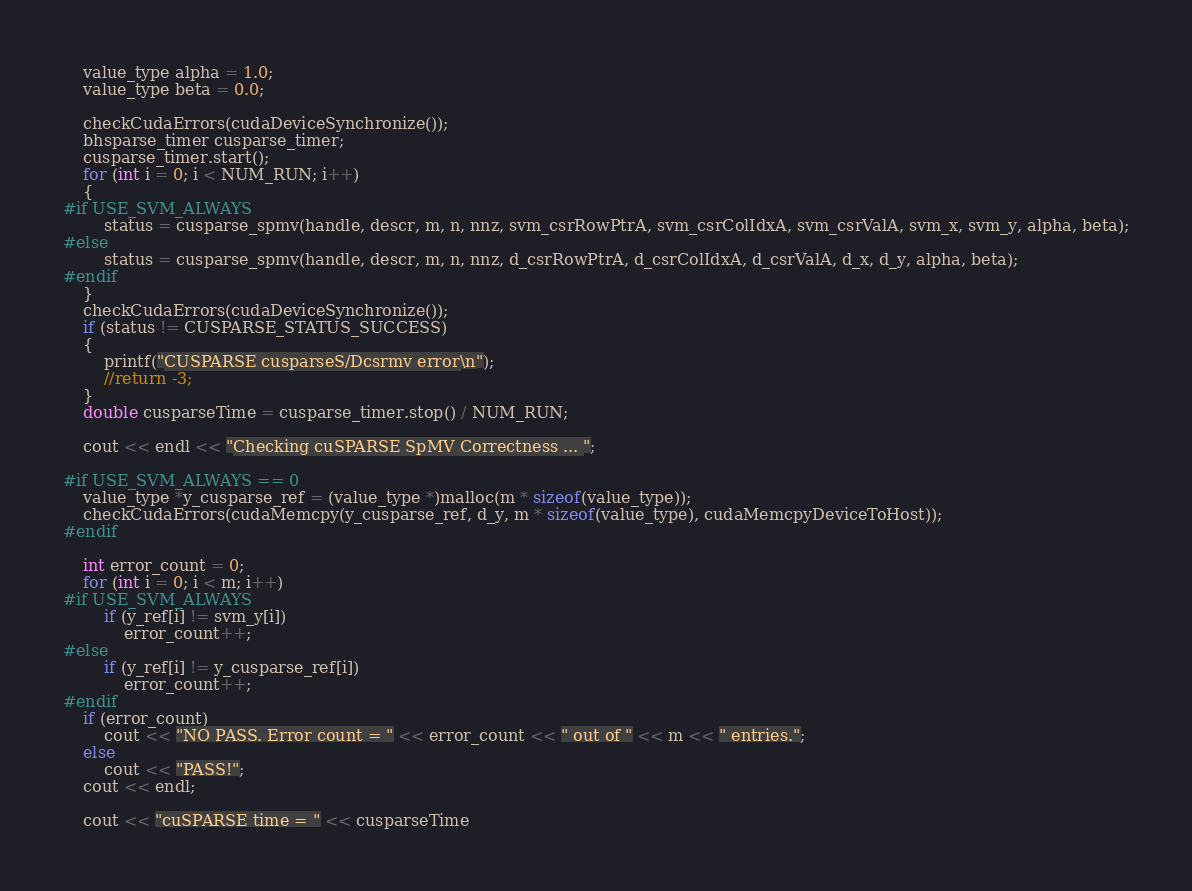Convert code to text. <code><loc_0><loc_0><loc_500><loc_500><_Cuda_>
    value_type alpha = 1.0;
    value_type beta = 0.0;

    checkCudaErrors(cudaDeviceSynchronize());
    bhsparse_timer cusparse_timer;
    cusparse_timer.start();
    for (int i = 0; i < NUM_RUN; i++)
    {
#if USE_SVM_ALWAYS
        status = cusparse_spmv(handle, descr, m, n, nnz, svm_csrRowPtrA, svm_csrColIdxA, svm_csrValA, svm_x, svm_y, alpha, beta);
#else
        status = cusparse_spmv(handle, descr, m, n, nnz, d_csrRowPtrA, d_csrColIdxA, d_csrValA, d_x, d_y, alpha, beta);
#endif
    }
    checkCudaErrors(cudaDeviceSynchronize());
    if (status != CUSPARSE_STATUS_SUCCESS)
    {
        printf("CUSPARSE cusparseS/Dcsrmv error\n");
        //return -3;
    }
    double cusparseTime = cusparse_timer.stop() / NUM_RUN;

    cout << endl << "Checking cuSPARSE SpMV Correctness ... ";

#if USE_SVM_ALWAYS == 0
    value_type *y_cusparse_ref = (value_type *)malloc(m * sizeof(value_type));
    checkCudaErrors(cudaMemcpy(y_cusparse_ref, d_y, m * sizeof(value_type), cudaMemcpyDeviceToHost));
#endif

    int error_count = 0;
    for (int i = 0; i < m; i++)
#if USE_SVM_ALWAYS
        if (y_ref[i] != svm_y[i])
            error_count++;
#else
        if (y_ref[i] != y_cusparse_ref[i])
            error_count++;
#endif
    if (error_count)
        cout << "NO PASS. Error count = " << error_count << " out of " << m << " entries.";
    else
        cout << "PASS!";
    cout << endl;

    cout << "cuSPARSE time = " << cusparseTime</code> 